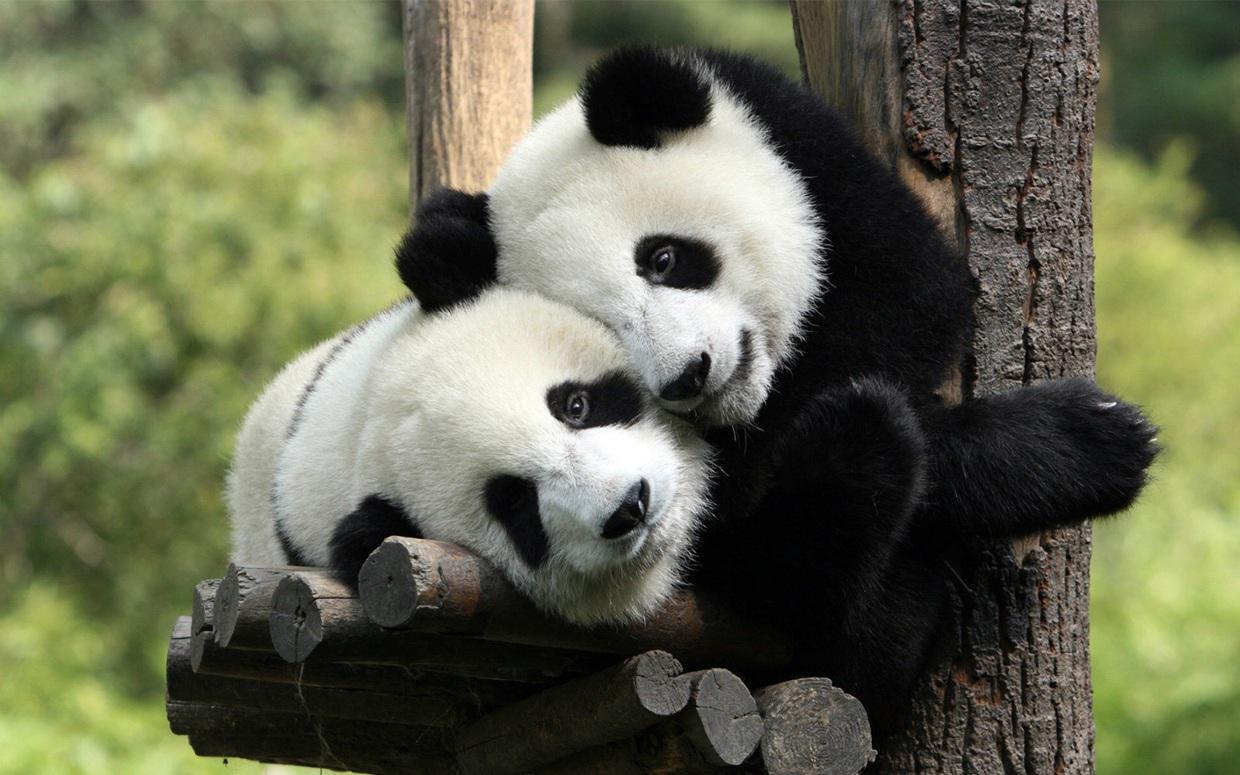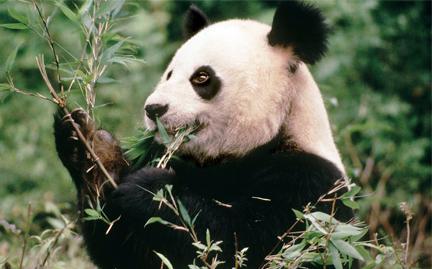The first image is the image on the left, the second image is the image on the right. Examine the images to the left and right. Is the description "there is exactly one panda in the image on the right." accurate? Answer yes or no. Yes. The first image is the image on the left, the second image is the image on the right. Considering the images on both sides, is "There are four pandas and a large panda's head is next to a smaller panda's head in at least one of the images." valid? Answer yes or no. No. 